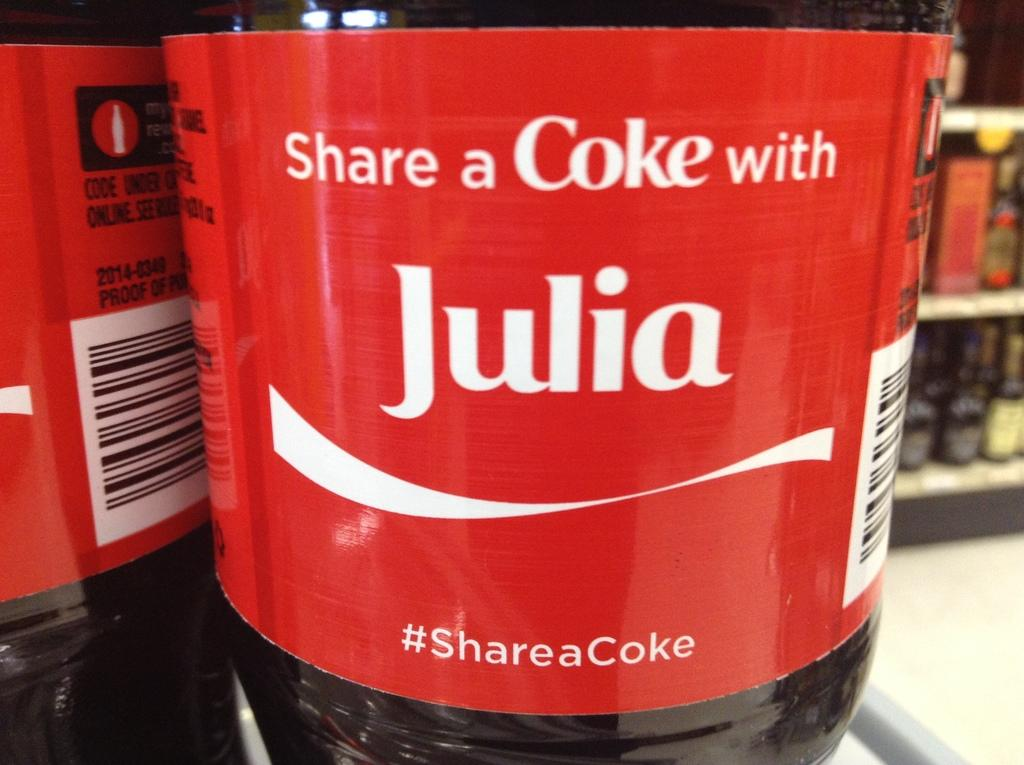<image>
Share a concise interpretation of the image provided. Liter coke bottle with the name Julia on it. 